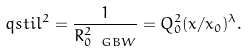<formula> <loc_0><loc_0><loc_500><loc_500>\ q s t i l ^ { 2 } = \frac { 1 } { R _ { 0 \ G B W } ^ { 2 } } = Q _ { 0 } ^ { 2 } ( x / x _ { 0 } ) ^ { \lambda } .</formula> 